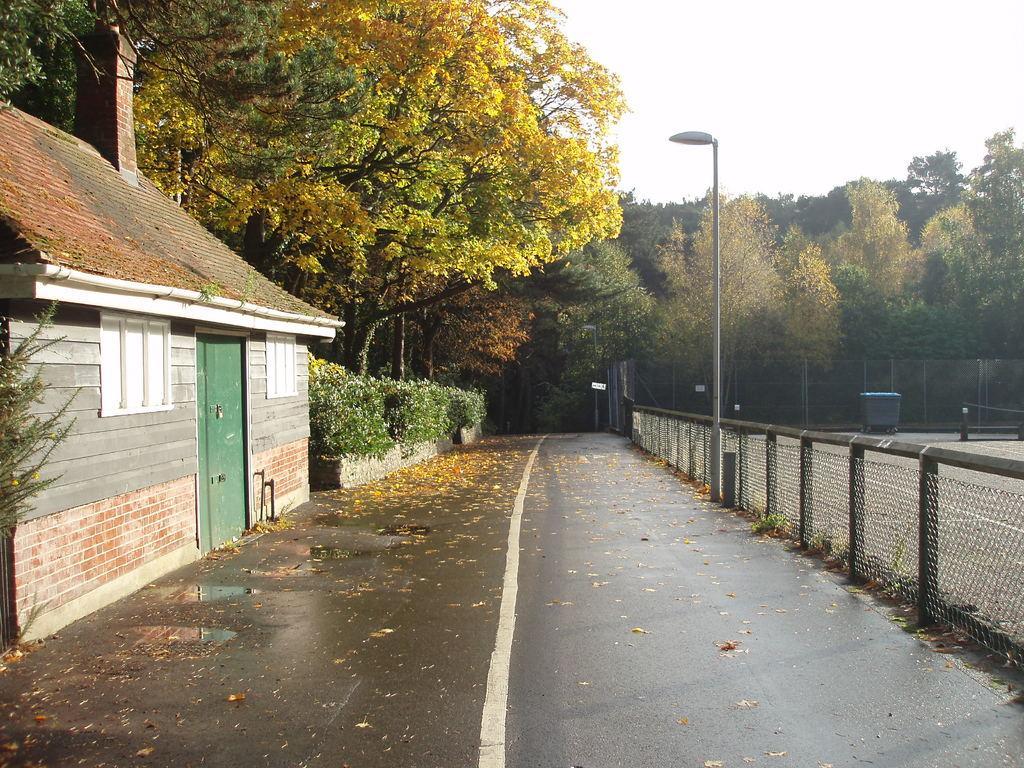Describe this image in one or two sentences. In this image there are leaves on the road, a house, few trees, fence, a bin in the court, street light and the sky. 